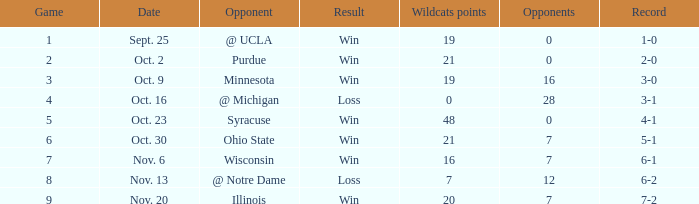How many triumphs or failures were there when the record stood at 3-0? 1.0. 